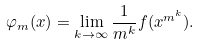Convert formula to latex. <formula><loc_0><loc_0><loc_500><loc_500>\varphi _ { m } ( x ) = \lim _ { k \to \infty } \frac { 1 } { m ^ { k } } f ( x ^ { m ^ { k } } ) .</formula> 